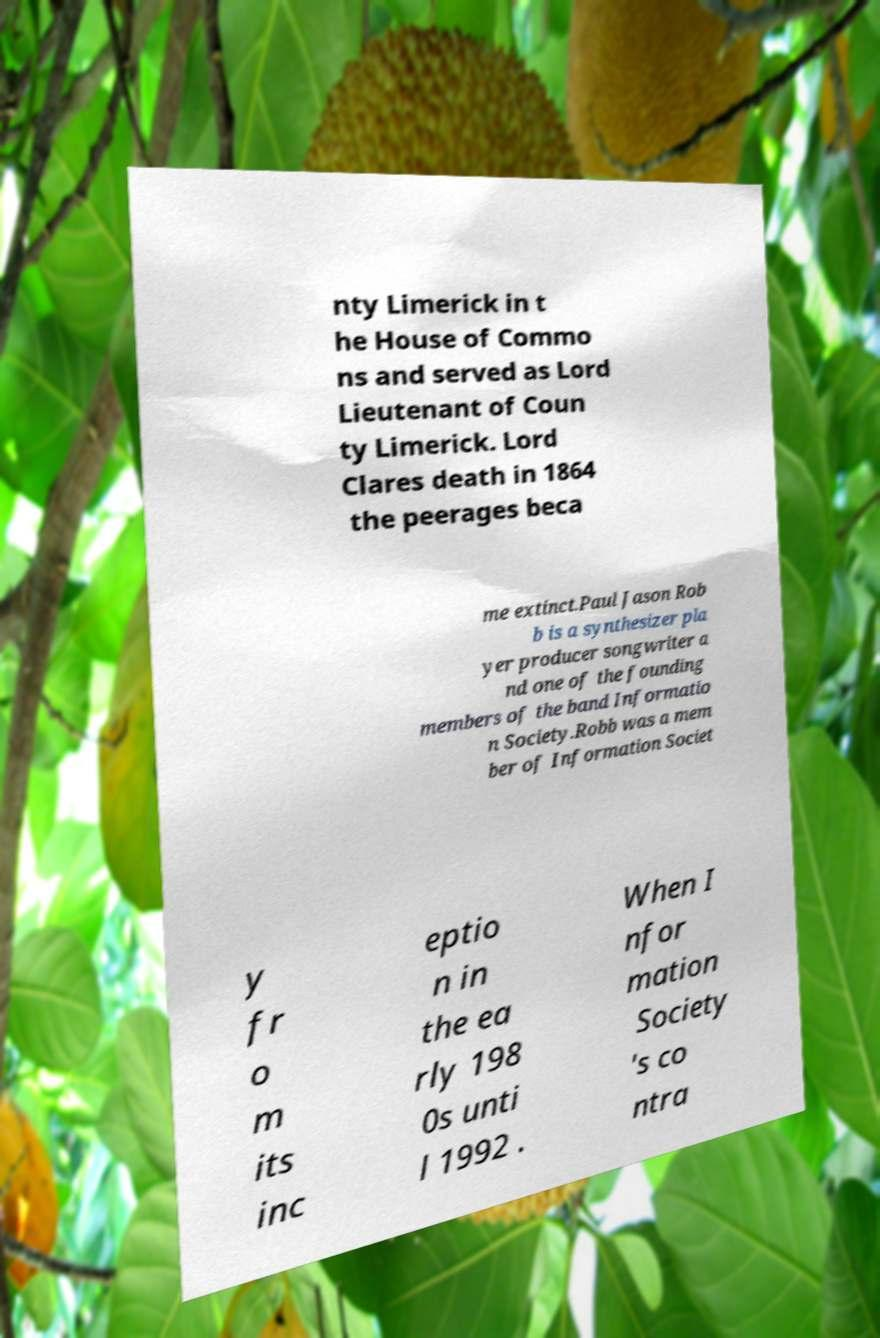Please identify and transcribe the text found in this image. nty Limerick in t he House of Commo ns and served as Lord Lieutenant of Coun ty Limerick. Lord Clares death in 1864 the peerages beca me extinct.Paul Jason Rob b is a synthesizer pla yer producer songwriter a nd one of the founding members of the band Informatio n Society.Robb was a mem ber of Information Societ y fr o m its inc eptio n in the ea rly 198 0s unti l 1992 . When I nfor mation Society 's co ntra 